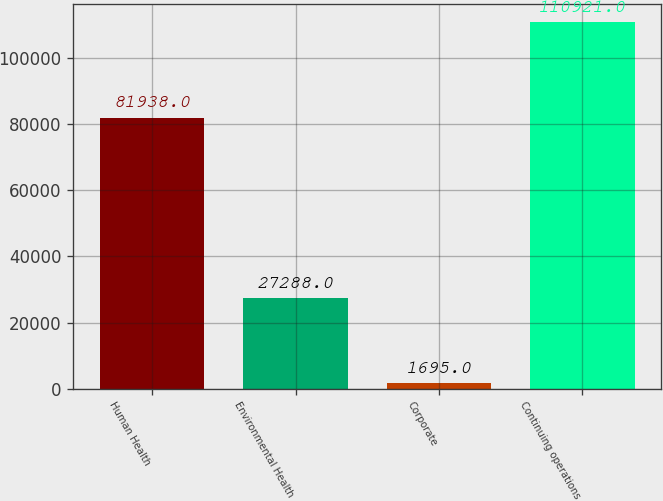Convert chart. <chart><loc_0><loc_0><loc_500><loc_500><bar_chart><fcel>Human Health<fcel>Environmental Health<fcel>Corporate<fcel>Continuing operations<nl><fcel>81938<fcel>27288<fcel>1695<fcel>110921<nl></chart> 